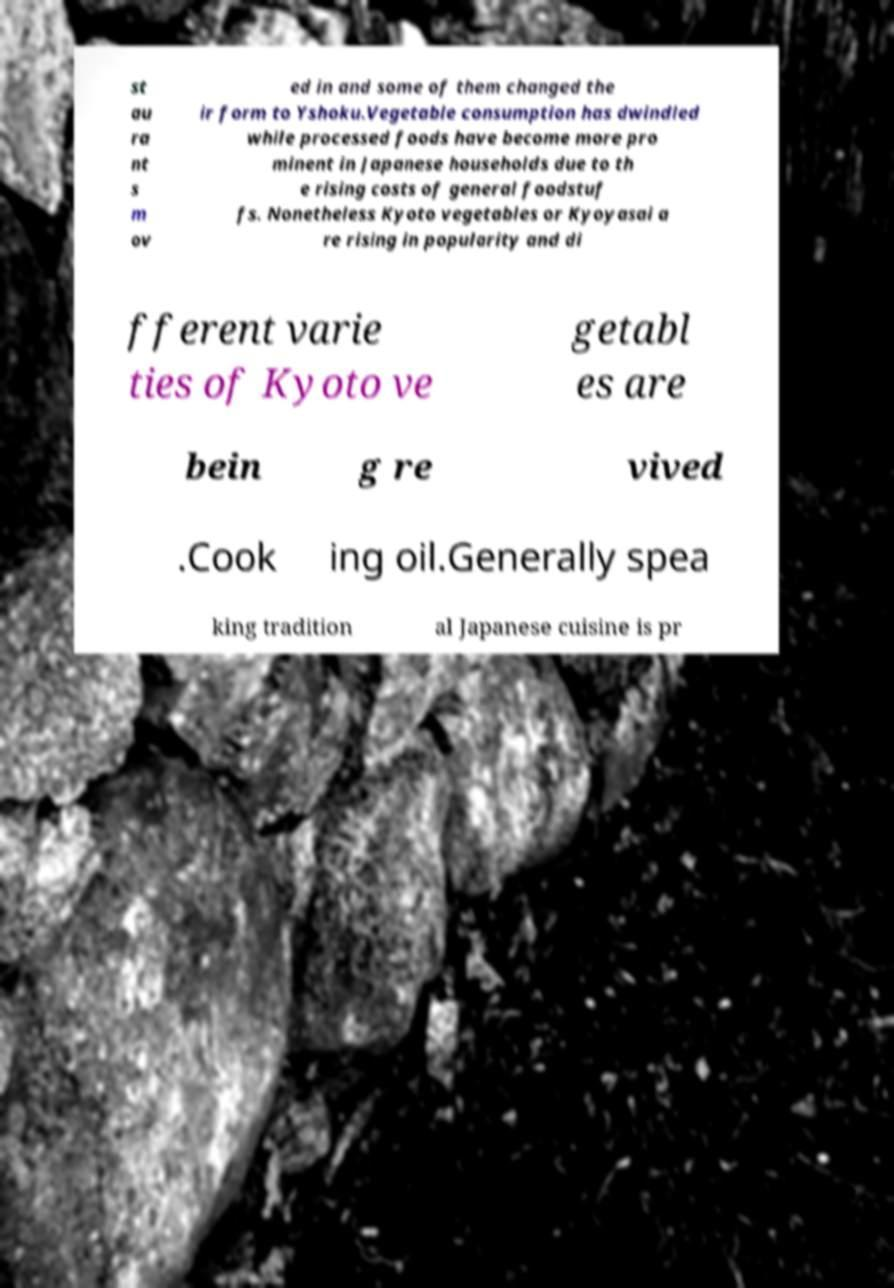Please identify and transcribe the text found in this image. st au ra nt s m ov ed in and some of them changed the ir form to Yshoku.Vegetable consumption has dwindled while processed foods have become more pro minent in Japanese households due to th e rising costs of general foodstuf fs. Nonetheless Kyoto vegetables or Kyoyasai a re rising in popularity and di fferent varie ties of Kyoto ve getabl es are bein g re vived .Cook ing oil.Generally spea king tradition al Japanese cuisine is pr 